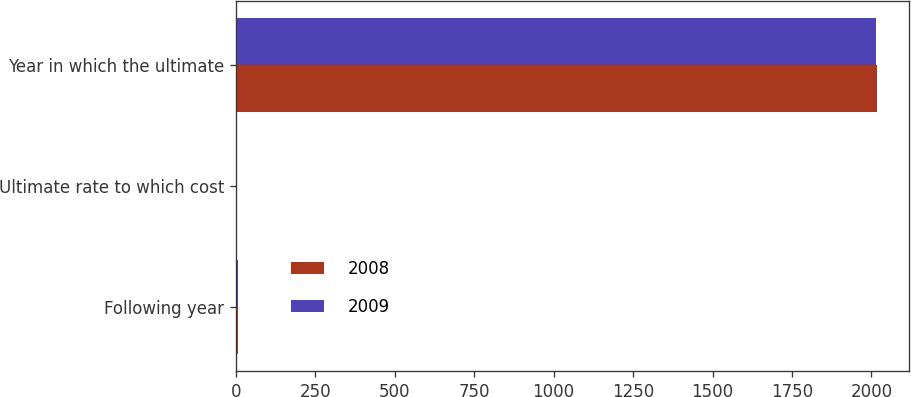<chart> <loc_0><loc_0><loc_500><loc_500><stacked_bar_chart><ecel><fcel>Following year<fcel>Ultimate rate to which cost<fcel>Year in which the ultimate<nl><fcel>2008<fcel>8<fcel>5<fcel>2016<nl><fcel>2009<fcel>7.5<fcel>5<fcel>2014<nl></chart> 